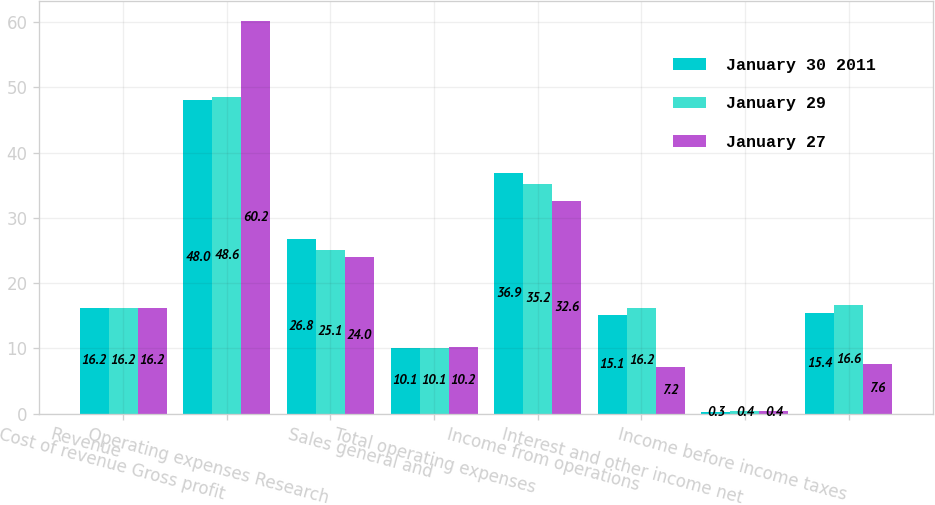Convert chart to OTSL. <chart><loc_0><loc_0><loc_500><loc_500><stacked_bar_chart><ecel><fcel>Revenue<fcel>Cost of revenue Gross profit<fcel>Operating expenses Research<fcel>Sales general and<fcel>Total operating expenses<fcel>Income from operations<fcel>Interest and other income net<fcel>Income before income taxes<nl><fcel>January 30 2011<fcel>16.2<fcel>48<fcel>26.8<fcel>10.1<fcel>36.9<fcel>15.1<fcel>0.3<fcel>15.4<nl><fcel>January 29<fcel>16.2<fcel>48.6<fcel>25.1<fcel>10.1<fcel>35.2<fcel>16.2<fcel>0.4<fcel>16.6<nl><fcel>January 27<fcel>16.2<fcel>60.2<fcel>24<fcel>10.2<fcel>32.6<fcel>7.2<fcel>0.4<fcel>7.6<nl></chart> 